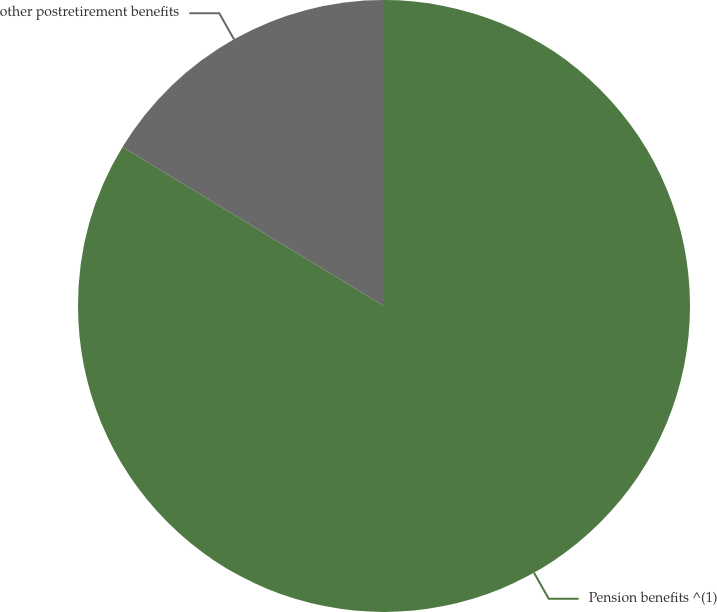Convert chart. <chart><loc_0><loc_0><loc_500><loc_500><pie_chart><fcel>Pension benefits ^(1)<fcel>other postretirement benefits<nl><fcel>83.69%<fcel>16.31%<nl></chart> 